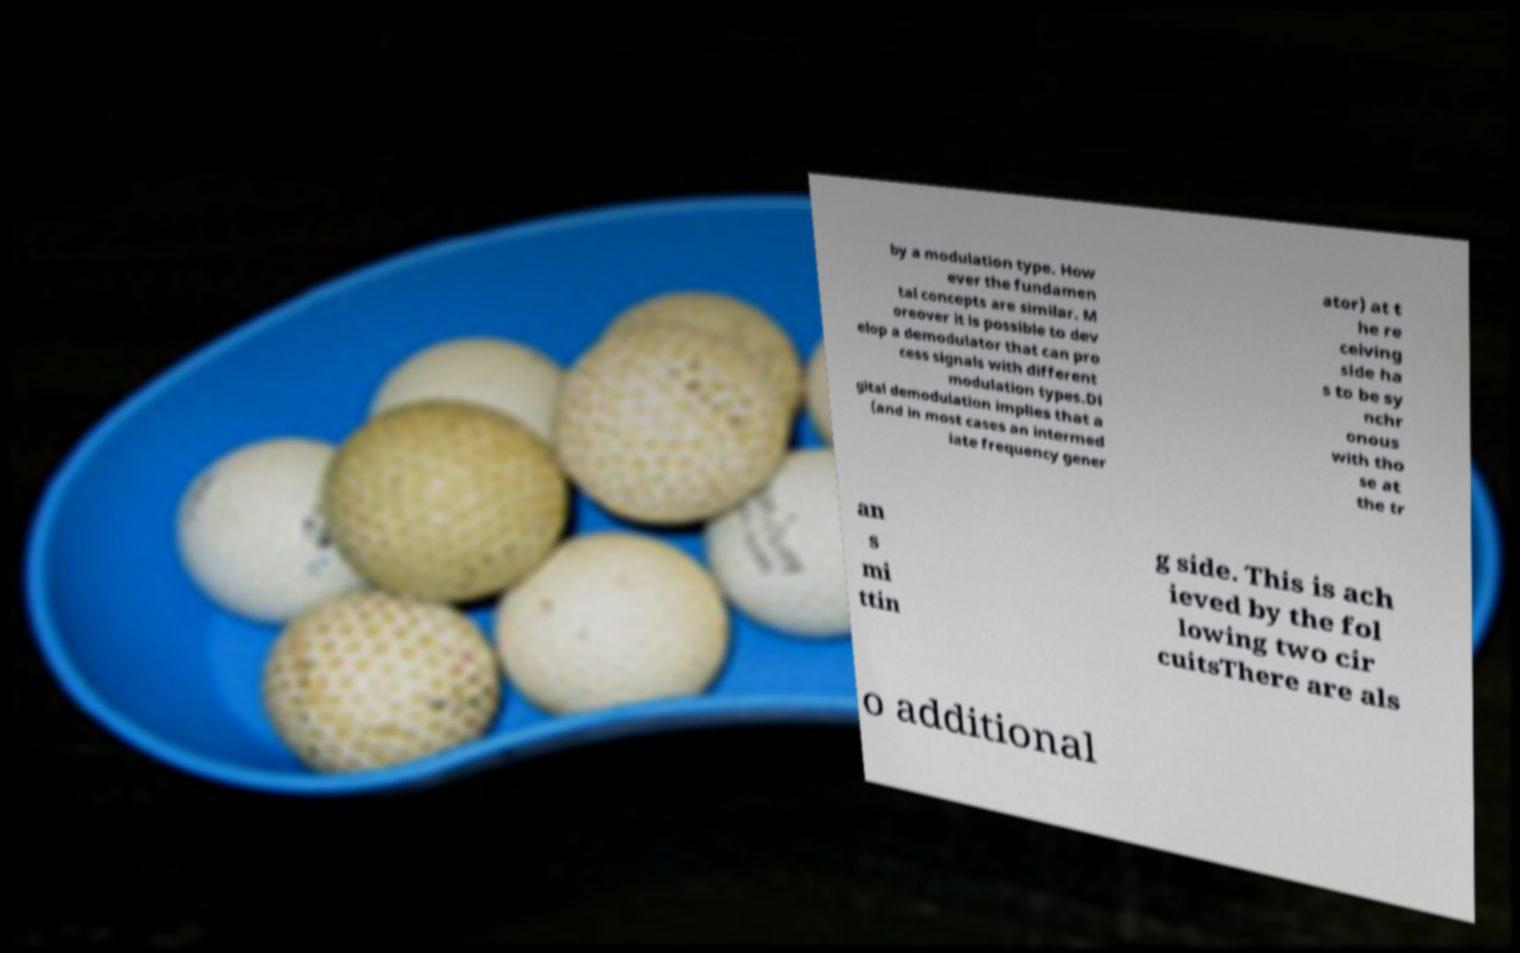Please read and relay the text visible in this image. What does it say? by a modulation type. How ever the fundamen tal concepts are similar. M oreover it is possible to dev elop a demodulator that can pro cess signals with different modulation types.Di gital demodulation implies that a (and in most cases an intermed iate frequency gener ator) at t he re ceiving side ha s to be sy nchr onous with tho se at the tr an s mi ttin g side. This is ach ieved by the fol lowing two cir cuitsThere are als o additional 